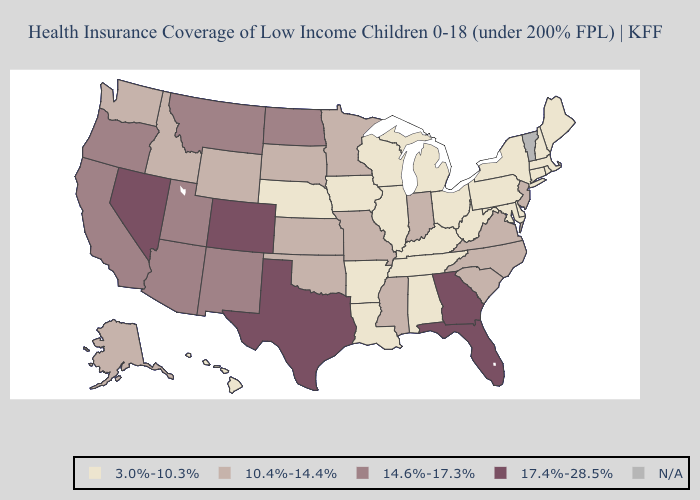What is the value of Missouri?
Quick response, please. 10.4%-14.4%. What is the value of Tennessee?
Answer briefly. 3.0%-10.3%. Name the states that have a value in the range 10.4%-14.4%?
Write a very short answer. Alaska, Idaho, Indiana, Kansas, Minnesota, Mississippi, Missouri, New Jersey, North Carolina, Oklahoma, South Carolina, South Dakota, Virginia, Washington, Wyoming. Among the states that border Tennessee , does Georgia have the highest value?
Short answer required. Yes. What is the highest value in states that border New Mexico?
Write a very short answer. 17.4%-28.5%. Which states have the lowest value in the MidWest?
Quick response, please. Illinois, Iowa, Michigan, Nebraska, Ohio, Wisconsin. Name the states that have a value in the range 14.6%-17.3%?
Be succinct. Arizona, California, Montana, New Mexico, North Dakota, Oregon, Utah. What is the lowest value in states that border New Jersey?
Keep it brief. 3.0%-10.3%. What is the highest value in the USA?
Answer briefly. 17.4%-28.5%. What is the highest value in the West ?
Answer briefly. 17.4%-28.5%. What is the value of New Hampshire?
Quick response, please. 3.0%-10.3%. Among the states that border Washington , does Oregon have the highest value?
Write a very short answer. Yes. Name the states that have a value in the range 17.4%-28.5%?
Answer briefly. Colorado, Florida, Georgia, Nevada, Texas. Name the states that have a value in the range 17.4%-28.5%?
Write a very short answer. Colorado, Florida, Georgia, Nevada, Texas. What is the value of Florida?
Concise answer only. 17.4%-28.5%. 